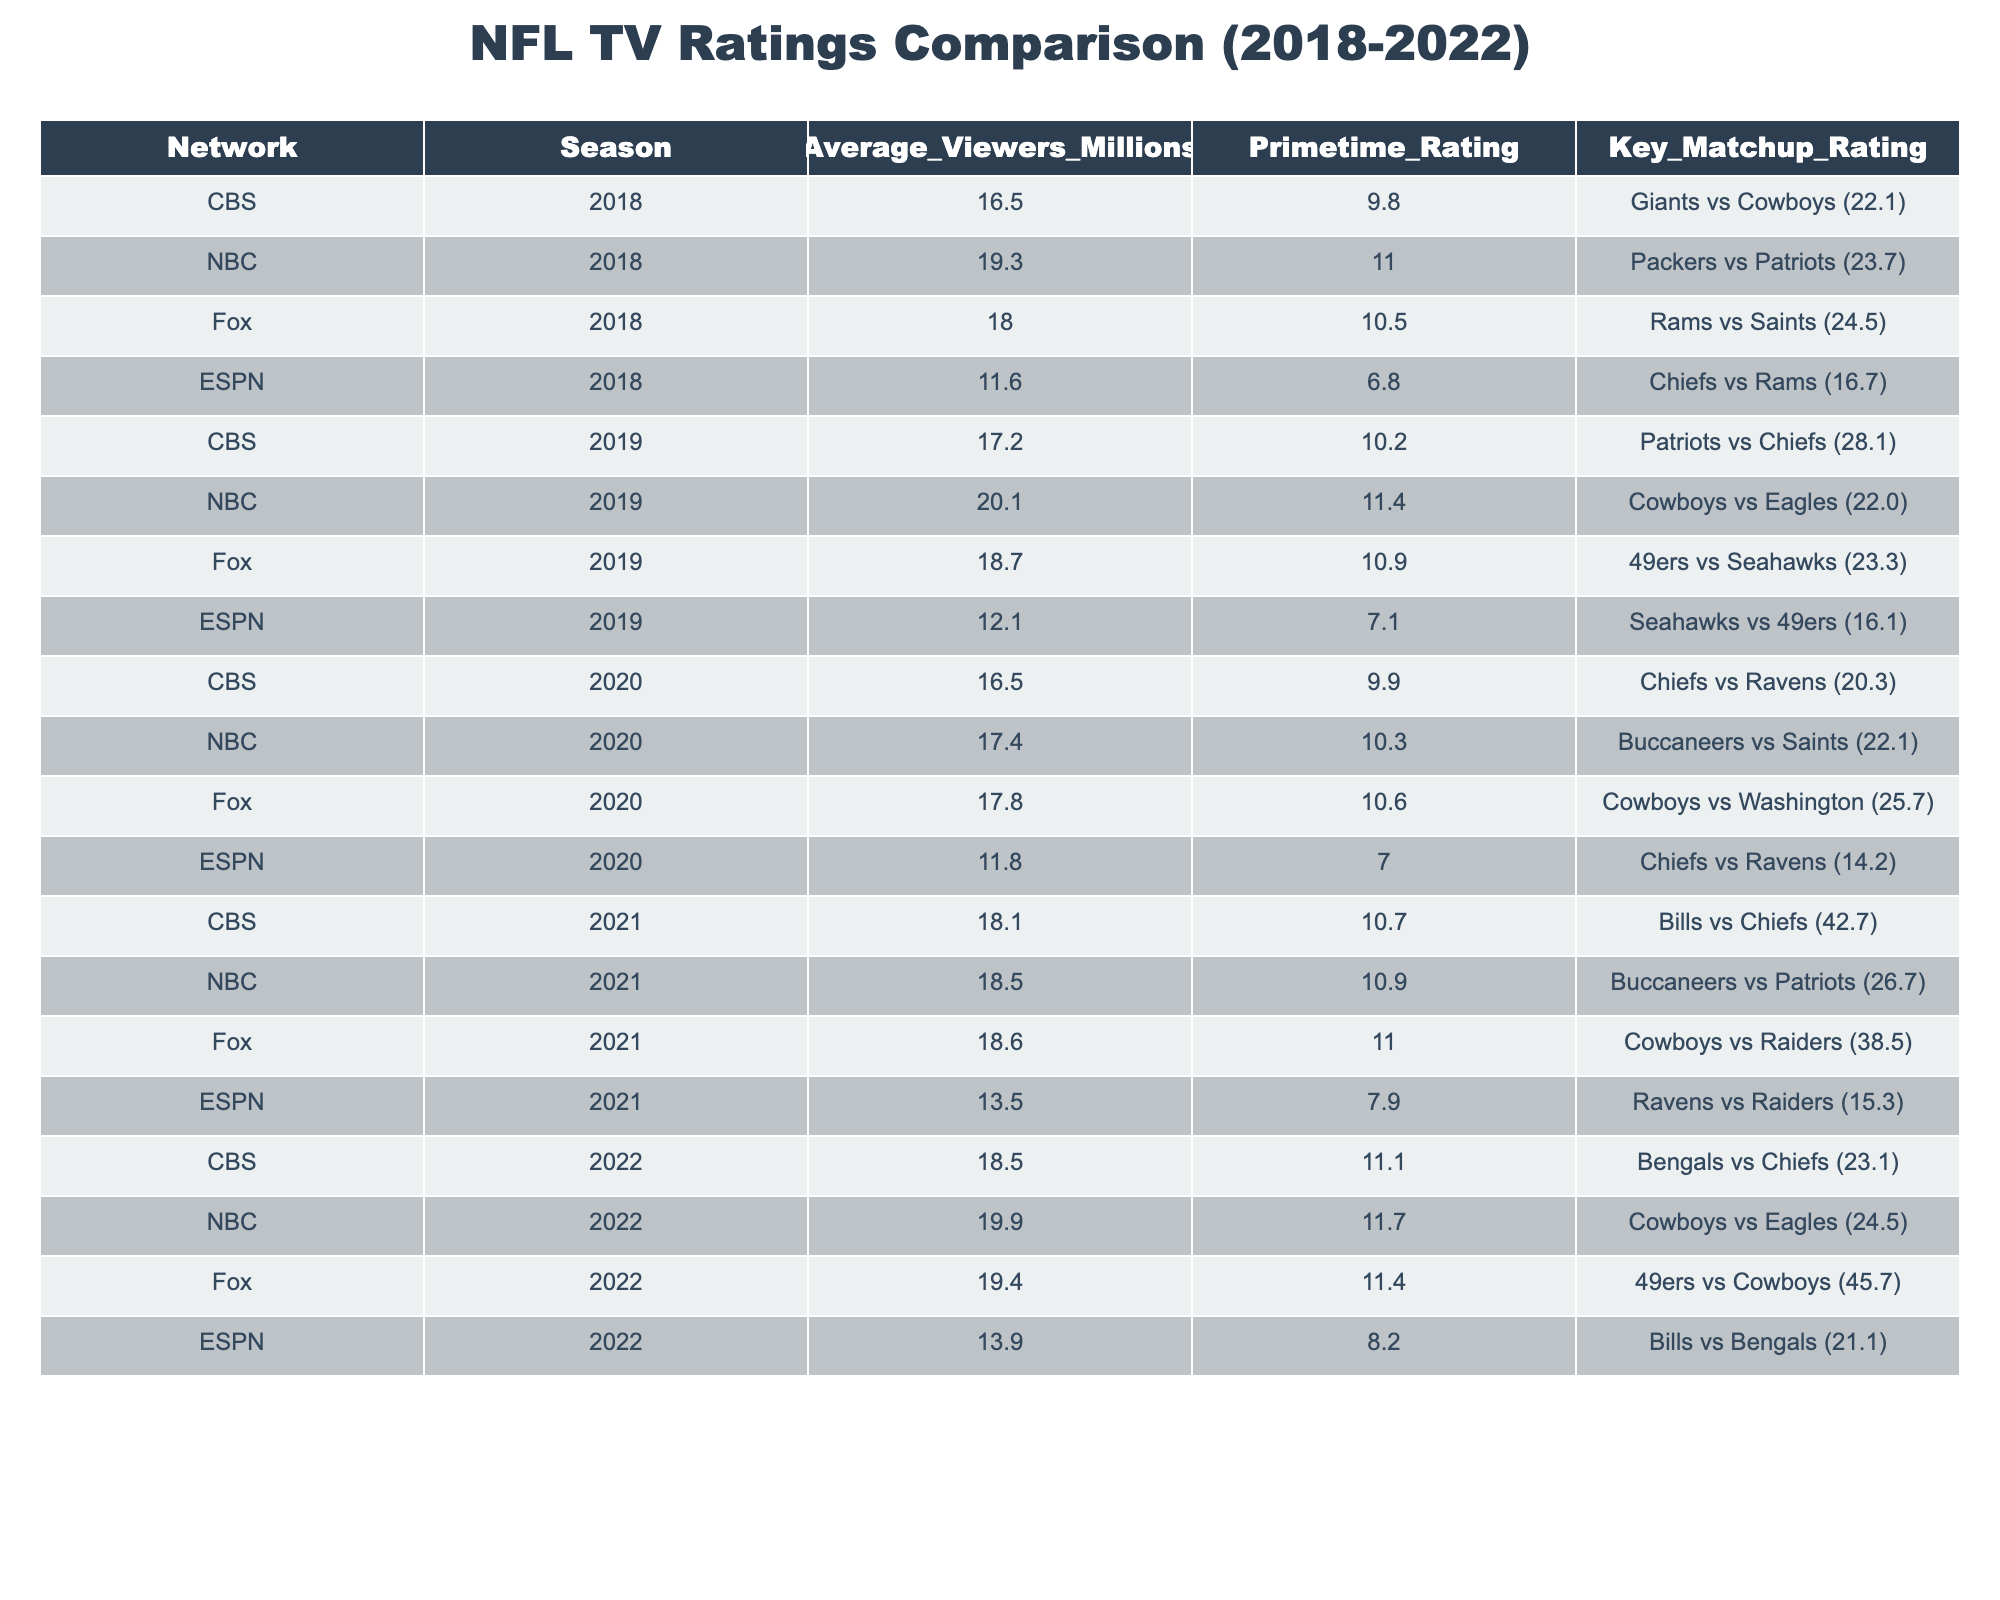What was the average viewership for NBC games in 2021? In 2021, the average viewership for NBC games was 18.5 million.
Answer: 18.5 million Which network had the highest average viewership in 2018? In 2018, NBC had the highest average viewership at 19.3 million.
Answer: NBC with 19.3 million How many seasons did ESPN have an average viewership above 12 million? ESPN had average viewership above 12 million in 2018 (11.6 million is below), 2019 (12.1 million is just at this mark), and 2021 (13.5 million). This means two seasons: 2019 and 2021.
Answer: 2 seasons What is the difference in average viewers between CBS and NBC in 2022? In 2022, CBS had 18.5 million and NBC had 19.9 million. The difference is 19.9 - 18.5 = 1.4 million.
Answer: 1.4 million Which network consistently had the lowest average viewership during the periods analyzed? ESPN had the lowest average viewership in all seasons analyzed, with its highest being 13.9 million in 2022, which is still below any above ESPN's 2021 average.
Answer: ESPN What was the highest key matchup rating for any network during the 5 seasons? The highest key matchup rating was 45.7, which was for Fox in the 2022 season with the matchup of 49ers vs Cowboys.
Answer: 45.7 Did the average viewership for CBS increase or decrease from 2018 to 2022? In 2018, CBS had 16.5 million viewers, and by 2022, it increased to 18.5 million viewers, indicating an increase.
Answer: Increased Which season had the highest average viewership overall and which network broadcast it? The season with the highest average viewership overall was 2019 with NBC at 20.1 million.
Answer: 2019 with NBC How do the average viewership numbers for Fox compare from 2018 to 2022? In 2018, Fox had 18.0 million viewers, and in 2022, it rose to 19.4 million. Thus, it increased by 1.4 million from 2018 to 2022.
Answer: Increased by 1.4 million In which season did CBS have its lowest average viewership, and what was that number? CBS had its lowest average viewership in 2018 with 16.5 million viewers.
Answer: 16.5 million in 2018 